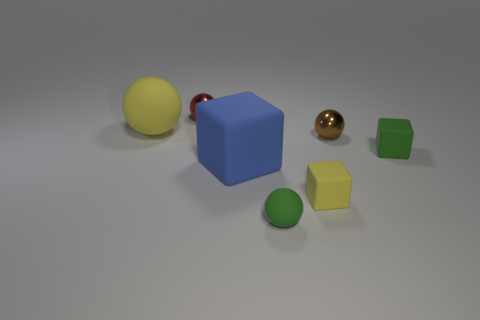There is a shiny sphere right of the small rubber cube left of the tiny green cube; what is its color?
Provide a succinct answer. Brown. Is the number of tiny brown metallic cylinders less than the number of blue things?
Give a very brief answer. Yes. Is there a tiny green sphere made of the same material as the blue object?
Provide a short and direct response. Yes. There is a brown shiny object; is it the same shape as the object that is behind the big yellow object?
Keep it short and to the point. Yes. Are there any shiny spheres to the right of the small red object?
Your answer should be compact. Yes. What number of other small metal things are the same shape as the tiny brown thing?
Keep it short and to the point. 1. Do the brown sphere and the tiny red ball on the left side of the yellow block have the same material?
Ensure brevity in your answer.  Yes. What number of green rubber things are there?
Make the answer very short. 2. There is a yellow object behind the large rubber cube; what is its size?
Your answer should be very brief. Large. How many green spheres have the same size as the green block?
Your response must be concise. 1. 